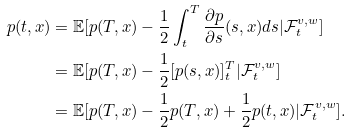Convert formula to latex. <formula><loc_0><loc_0><loc_500><loc_500>p ( t , x ) & = \mathbb { E } [ p ( T , x ) - \frac { 1 } { 2 } \int _ { t } ^ { T } \frac { \partial p } { \partial s } ( s , x ) d s | \mathcal { F } ^ { v , w } _ { t } ] \\ & = \mathbb { E } [ p ( T , x ) - \frac { 1 } { 2 } [ p ( s , x ) ] _ { t } ^ { T } | \mathcal { F } ^ { v , w } _ { t } ] \\ & = \mathbb { E } [ p ( T , x ) - \frac { 1 } { 2 } p ( T , x ) + \frac { 1 } { 2 } p ( t , x ) | \mathcal { F } ^ { v , w } _ { t } ] .</formula> 